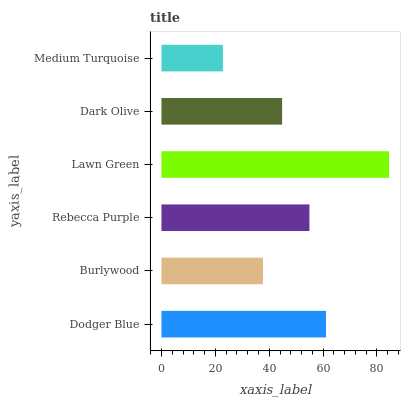Is Medium Turquoise the minimum?
Answer yes or no. Yes. Is Lawn Green the maximum?
Answer yes or no. Yes. Is Burlywood the minimum?
Answer yes or no. No. Is Burlywood the maximum?
Answer yes or no. No. Is Dodger Blue greater than Burlywood?
Answer yes or no. Yes. Is Burlywood less than Dodger Blue?
Answer yes or no. Yes. Is Burlywood greater than Dodger Blue?
Answer yes or no. No. Is Dodger Blue less than Burlywood?
Answer yes or no. No. Is Rebecca Purple the high median?
Answer yes or no. Yes. Is Dark Olive the low median?
Answer yes or no. Yes. Is Dodger Blue the high median?
Answer yes or no. No. Is Medium Turquoise the low median?
Answer yes or no. No. 